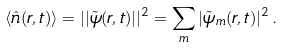<formula> <loc_0><loc_0><loc_500><loc_500>\langle \hat { n } ( { r } , t ) \rangle = | | \tilde { \psi } ( { r } , t ) | | ^ { 2 } = \sum _ { m } | \tilde { \psi } _ { m } ( { r } , t ) | ^ { 2 } \, .</formula> 